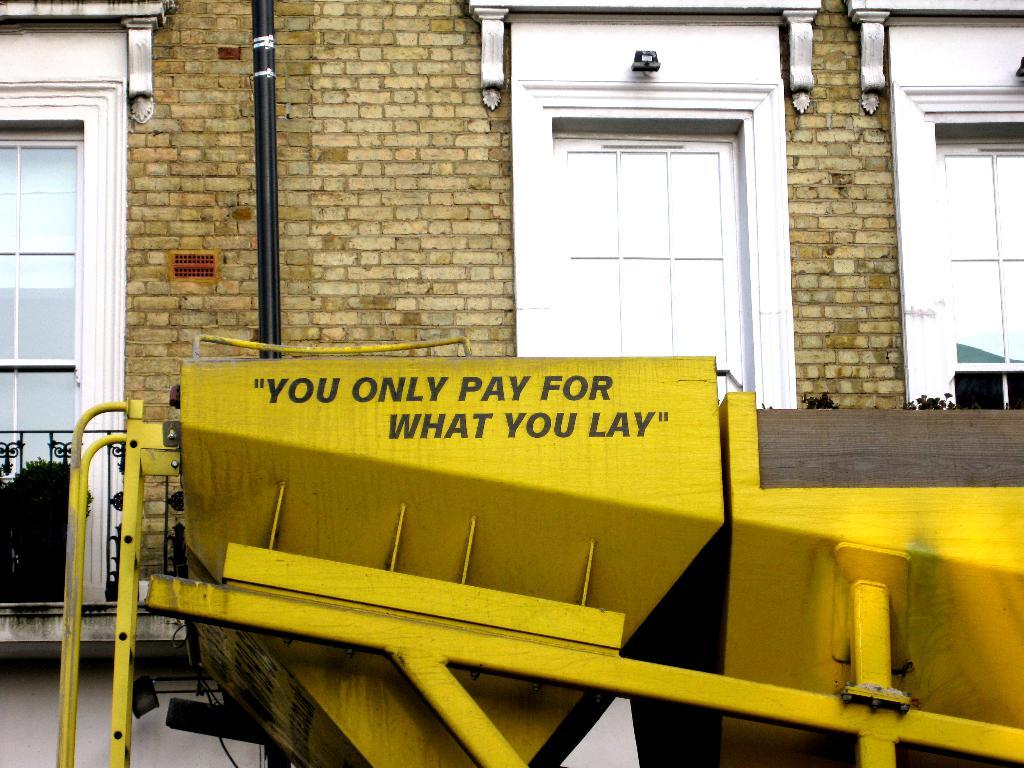What type of structure is visible in the image? There is a building in the image. What materials can be seen in the image? Metal rods and a pipe are visible in the image. What is located in front of the building in the image? There is a machine in front of the building in the image. Can you tell me how much the bee is charging for its services in the image? There is no bee present in the image, and therefore no services or charges can be observed. 